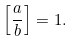Convert formula to latex. <formula><loc_0><loc_0><loc_500><loc_500>\left [ { \frac { a } { b } } \right ] = 1 .</formula> 